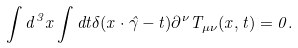Convert formula to latex. <formula><loc_0><loc_0><loc_500><loc_500>\int d ^ { 3 } x \int d t \delta ( { x } \cdot \hat { \gamma } - t ) \partial ^ { \nu } T _ { \mu \nu } ( { x } , t ) = 0 .</formula> 